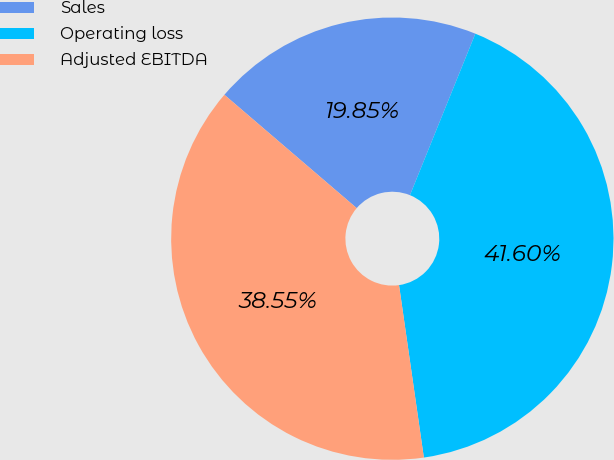Convert chart. <chart><loc_0><loc_0><loc_500><loc_500><pie_chart><fcel>Sales<fcel>Operating loss<fcel>Adjusted EBITDA<nl><fcel>19.85%<fcel>41.6%<fcel>38.55%<nl></chart> 